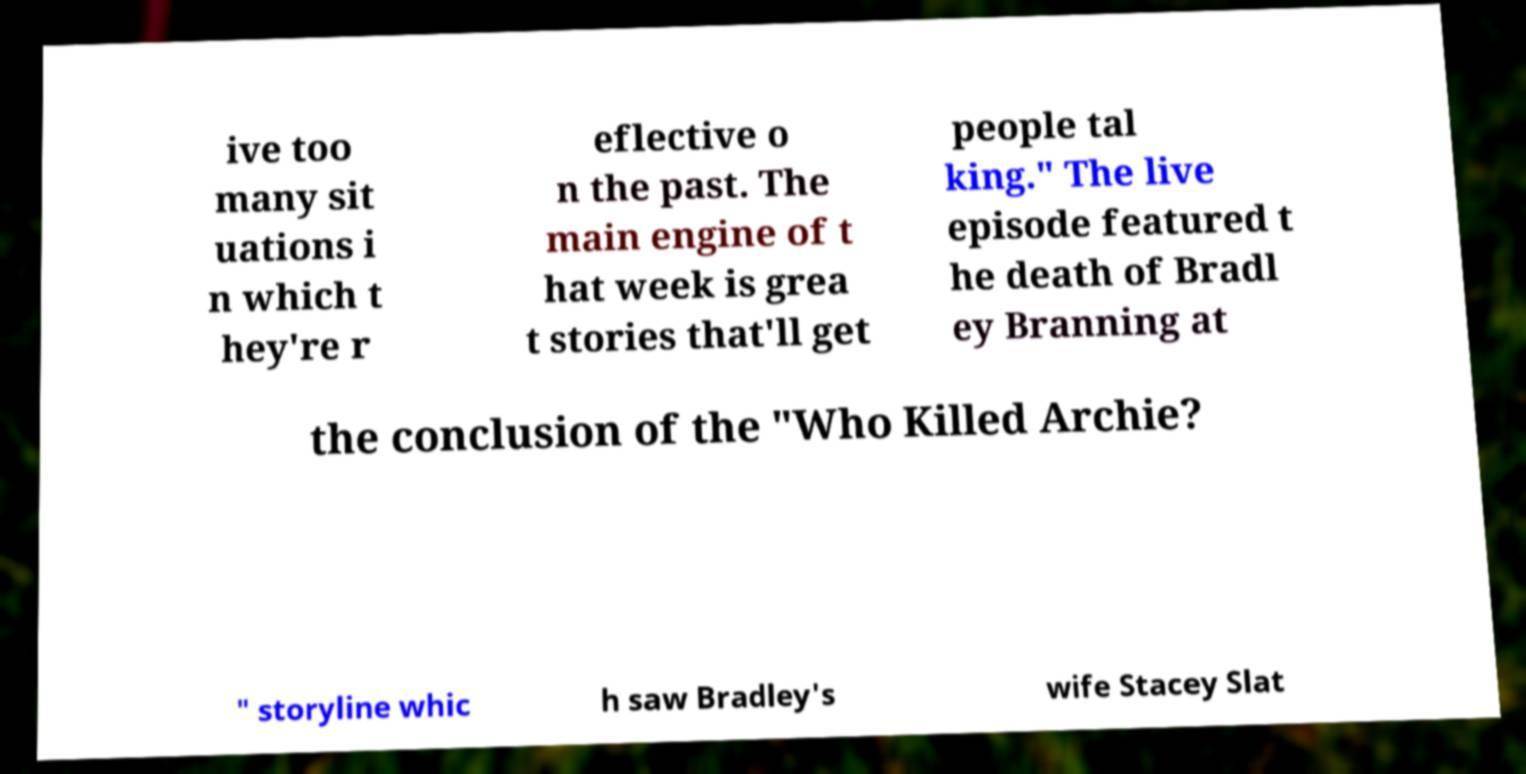I need the written content from this picture converted into text. Can you do that? ive too many sit uations i n which t hey're r eflective o n the past. The main engine of t hat week is grea t stories that'll get people tal king." The live episode featured t he death of Bradl ey Branning at the conclusion of the "Who Killed Archie? " storyline whic h saw Bradley's wife Stacey Slat 